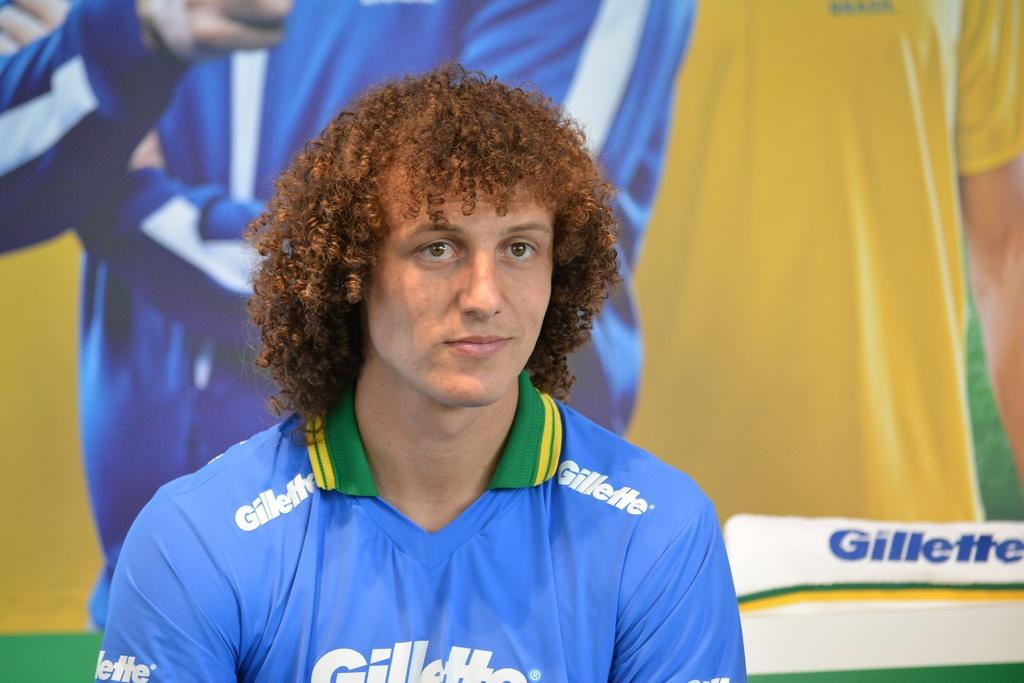What can be seen in the image? There is a person in the image. Can you describe the person's appearance? The person has curly hair and is wearing a blue t-shirt. What else is visible in the image? There is a poster visible in the image. Is there a woman standing next to the mailbox in the image? There is no mention of a woman or a mailbox in the provided facts, so we cannot answer this question based on the image. 